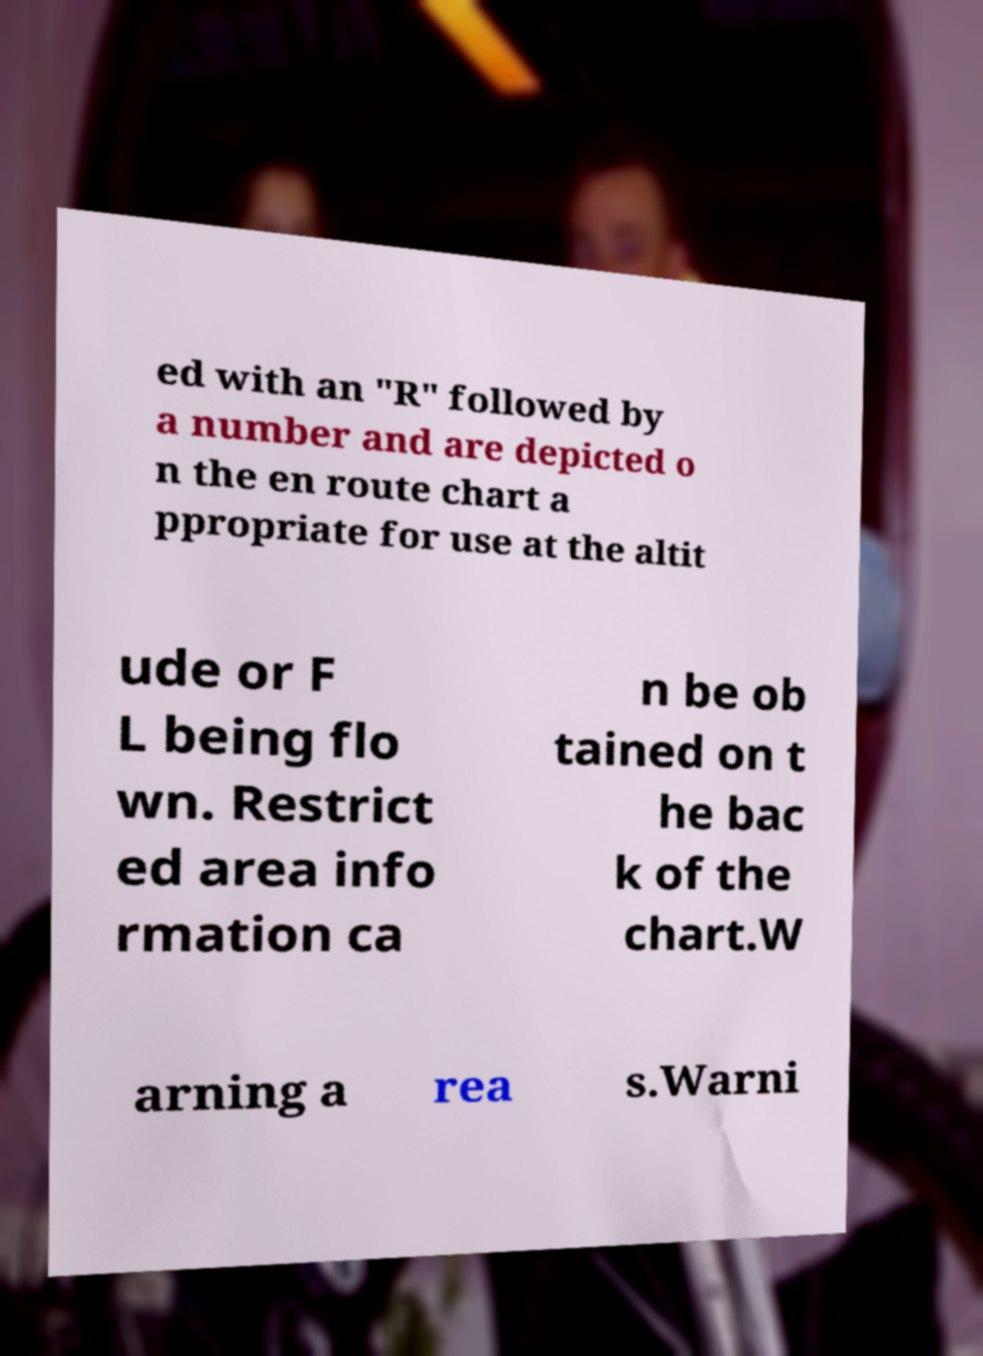Please read and relay the text visible in this image. What does it say? ed with an "R" followed by a number and are depicted o n the en route chart a ppropriate for use at the altit ude or F L being flo wn. Restrict ed area info rmation ca n be ob tained on t he bac k of the chart.W arning a rea s.Warni 